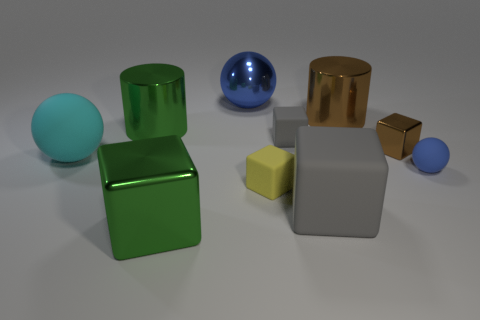There is another gray matte object that is the same shape as the large gray matte thing; what is its size?
Provide a succinct answer. Small. What color is the big metallic object that is the same shape as the small brown thing?
Keep it short and to the point. Green. How many blocks are made of the same material as the big blue thing?
Keep it short and to the point. 2. Is the shape of the metal thing behind the big brown cylinder the same as the matte thing that is to the left of the big blue metal thing?
Provide a short and direct response. Yes. The large rubber sphere behind the blue matte thing is what color?
Provide a succinct answer. Cyan. Are there any gray rubber objects of the same shape as the big brown thing?
Provide a short and direct response. No. What is the material of the big blue object?
Offer a very short reply. Metal. What is the size of the metallic thing that is to the right of the yellow matte thing and in front of the large brown shiny thing?
Your answer should be compact. Small. There is a large sphere that is the same color as the tiny ball; what is its material?
Ensure brevity in your answer.  Metal. How many shiny cylinders are there?
Provide a succinct answer. 2. 